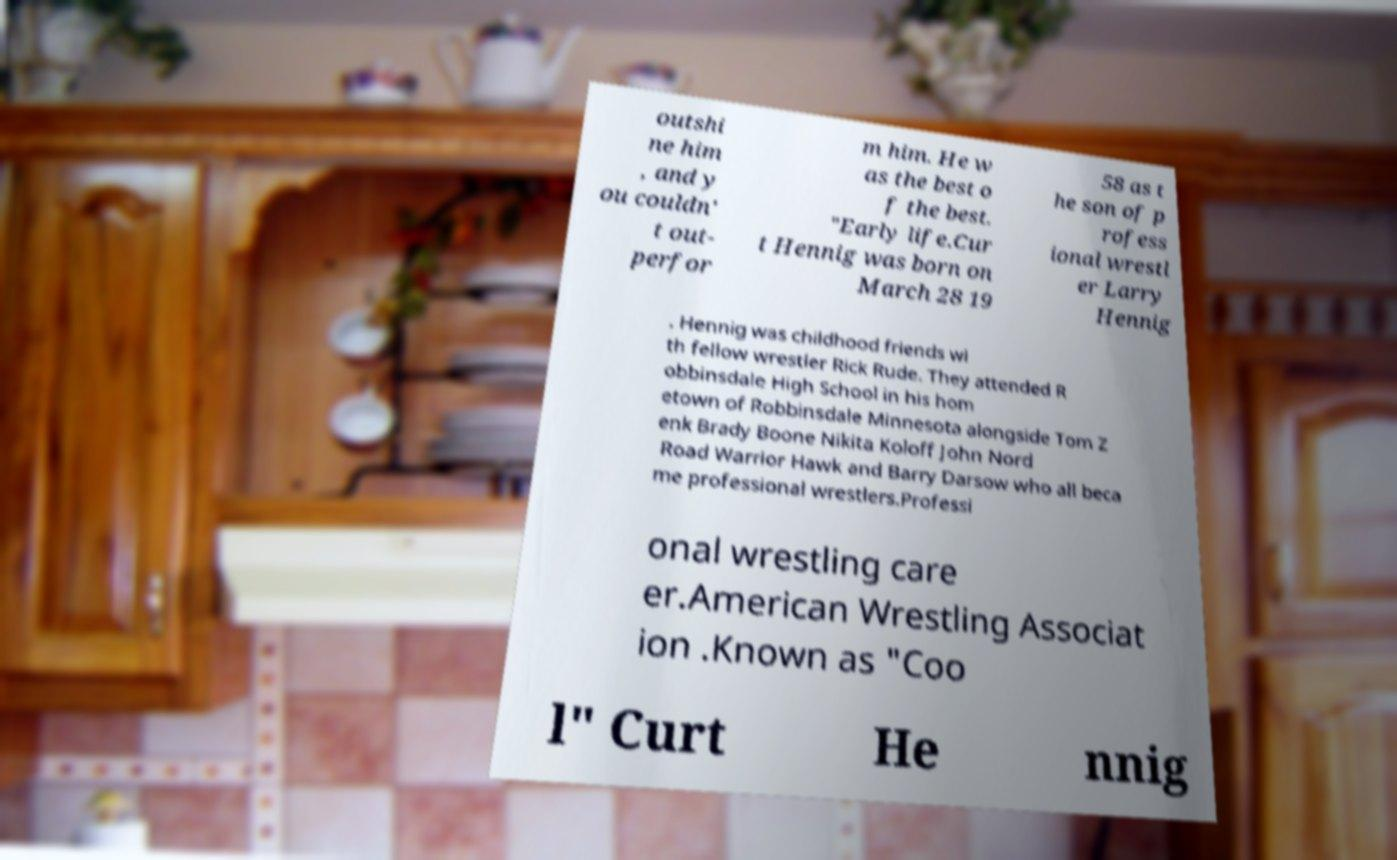Can you accurately transcribe the text from the provided image for me? outshi ne him , and y ou couldn' t out- perfor m him. He w as the best o f the best. "Early life.Cur t Hennig was born on March 28 19 58 as t he son of p rofess ional wrestl er Larry Hennig . Hennig was childhood friends wi th fellow wrestler Rick Rude. They attended R obbinsdale High School in his hom etown of Robbinsdale Minnesota alongside Tom Z enk Brady Boone Nikita Koloff John Nord Road Warrior Hawk and Barry Darsow who all beca me professional wrestlers.Professi onal wrestling care er.American Wrestling Associat ion .Known as "Coo l" Curt He nnig 